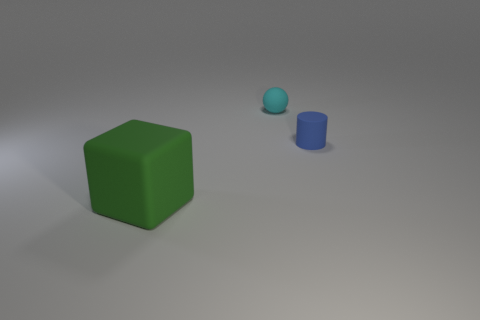Add 3 small purple matte objects. How many objects exist? 6 Subtract all cubes. How many objects are left? 2 Add 1 tiny green rubber cylinders. How many tiny green rubber cylinders exist? 1 Subtract 0 purple balls. How many objects are left? 3 Subtract all tiny cyan matte balls. Subtract all tiny brown metallic cylinders. How many objects are left? 2 Add 1 big green blocks. How many big green blocks are left? 2 